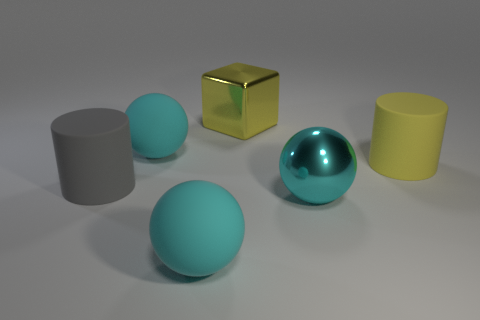Subtract all cyan spheres. How many were subtracted if there are1cyan spheres left? 2 Subtract all shiny balls. How many balls are left? 2 Subtract all yellow cylinders. Subtract all brown things. How many objects are left? 5 Add 6 cubes. How many cubes are left? 7 Add 1 large green rubber cubes. How many large green rubber cubes exist? 1 Add 3 small matte blocks. How many objects exist? 9 Subtract all yellow cylinders. How many cylinders are left? 1 Subtract 0 brown spheres. How many objects are left? 6 Subtract all blocks. How many objects are left? 5 Subtract 1 spheres. How many spheres are left? 2 